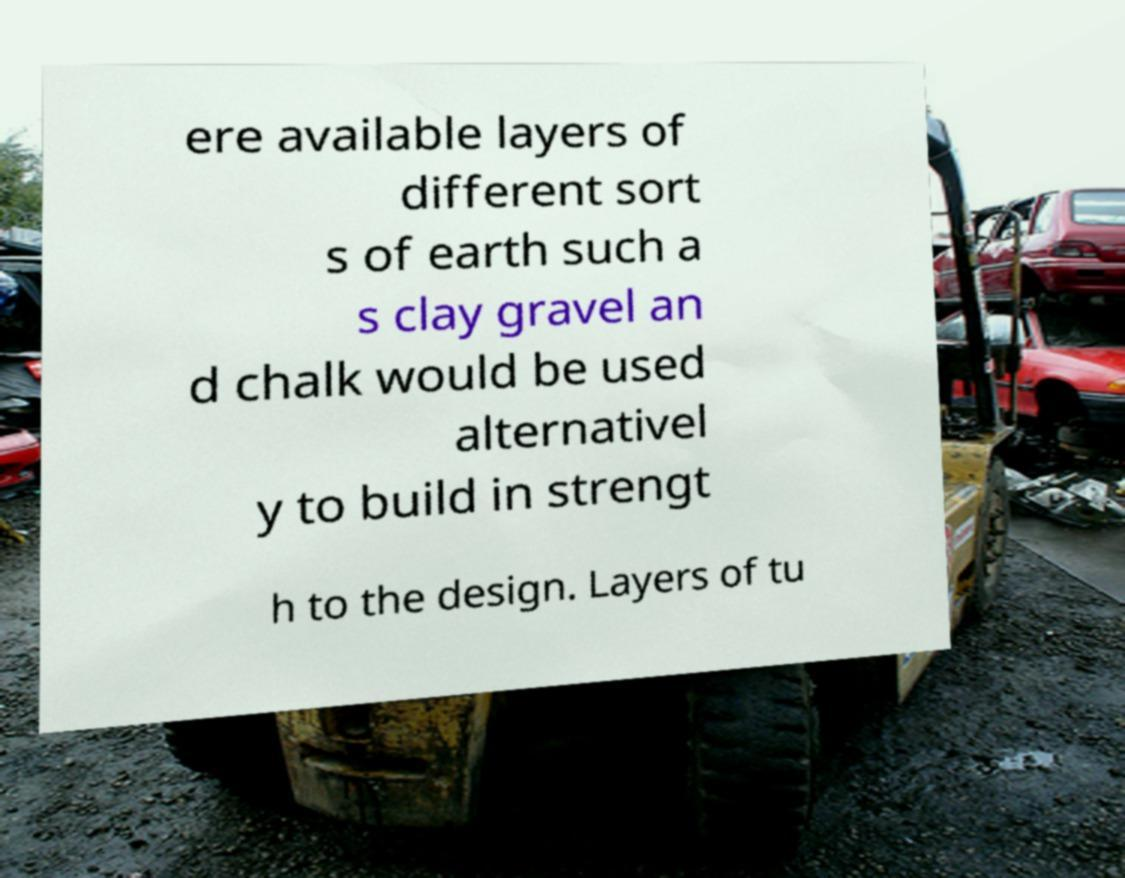Please identify and transcribe the text found in this image. ere available layers of different sort s of earth such a s clay gravel an d chalk would be used alternativel y to build in strengt h to the design. Layers of tu 